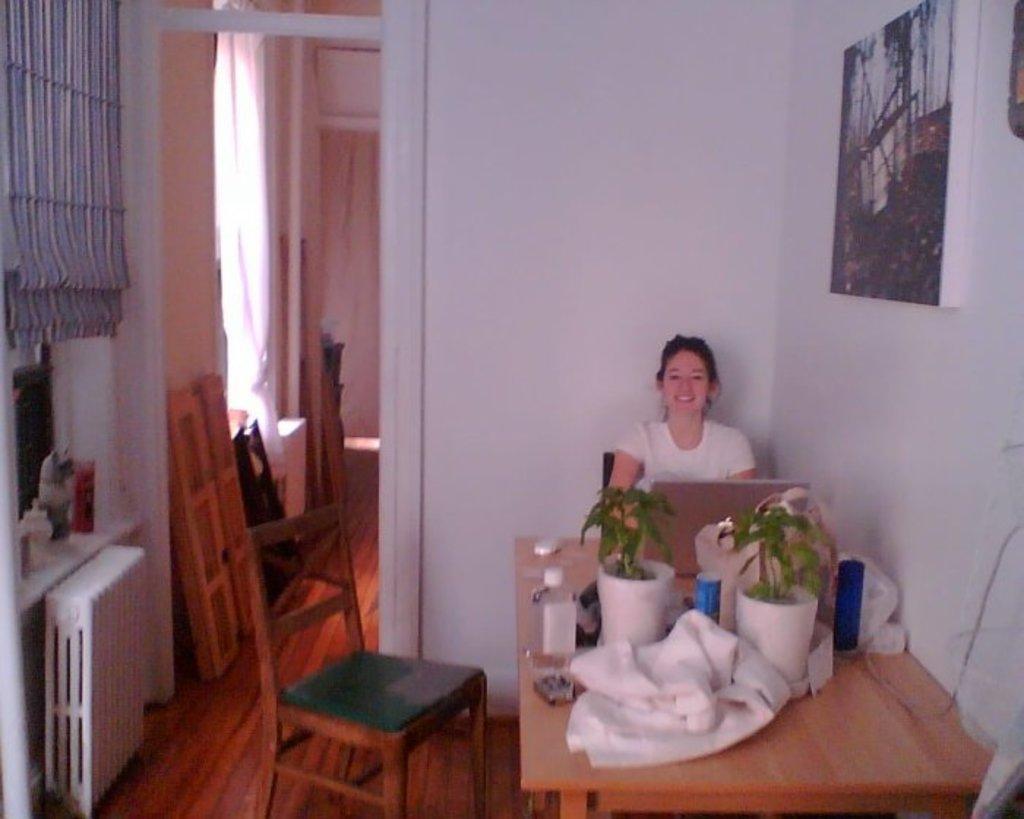Describe this image in one or two sentences. This is the woman sitting on the chair and smiling. This is the table with two flower pots,bottle,blanket and some objects on it. This looks like a laptop. I can find and empty chair here. This is the frame attached to the wall. At background I can see curtain hanging and some wooden object placed aside. I think this is a cloth hanging and some objects placed here. 